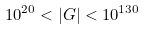Convert formula to latex. <formula><loc_0><loc_0><loc_500><loc_500>1 0 ^ { 2 0 } < | G | < 1 0 ^ { 1 3 0 }</formula> 